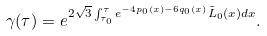<formula> <loc_0><loc_0><loc_500><loc_500>\gamma ( \tau ) = e ^ { 2 \sqrt { 3 } \int _ { \tau _ { 0 } } ^ { \tau } e ^ { - 4 p _ { 0 } ( x ) - 6 q _ { 0 } ( x ) } \tilde { L } _ { 0 } ( x ) d x } .</formula> 